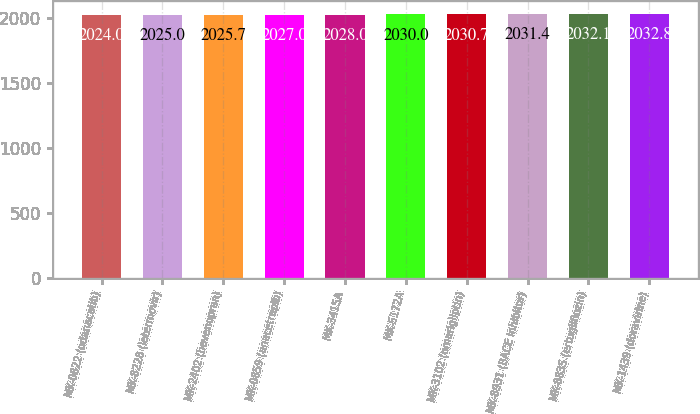Convert chart to OTSL. <chart><loc_0><loc_0><loc_500><loc_500><bar_chart><fcel>MK-0822 (odanacatib)<fcel>MK-8228 (letermovir)<fcel>MK-2402 (bevenopran)<fcel>MK-0859 (anacetrapib)<fcel>MK-3415A<fcel>MK-5172A<fcel>MK-3102 (omarigliptin)<fcel>MK-8931 (BACE Inhibitor)<fcel>MK-8835 (ertugliflozin)<fcel>MK-1439 (doravirine)<nl><fcel>2024<fcel>2025<fcel>2025.7<fcel>2027<fcel>2028<fcel>2030<fcel>2030.7<fcel>2031.4<fcel>2032.1<fcel>2032.8<nl></chart> 